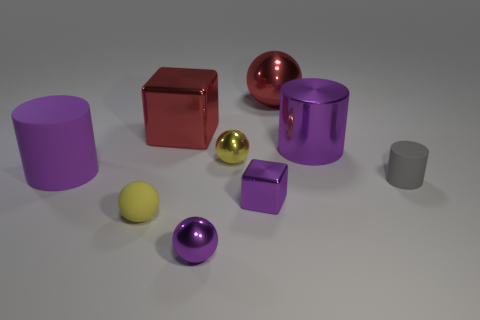Can you describe the composition of the objects in terms of color harmony? The image features a color palette with both complementary colors—red and green shades—as seen with the red cube and the smaller greenish sphere, and analogous colors—various shades of purple—that create a sense of harmony. These color choices balance the composition and create a visually pleasant scene. 